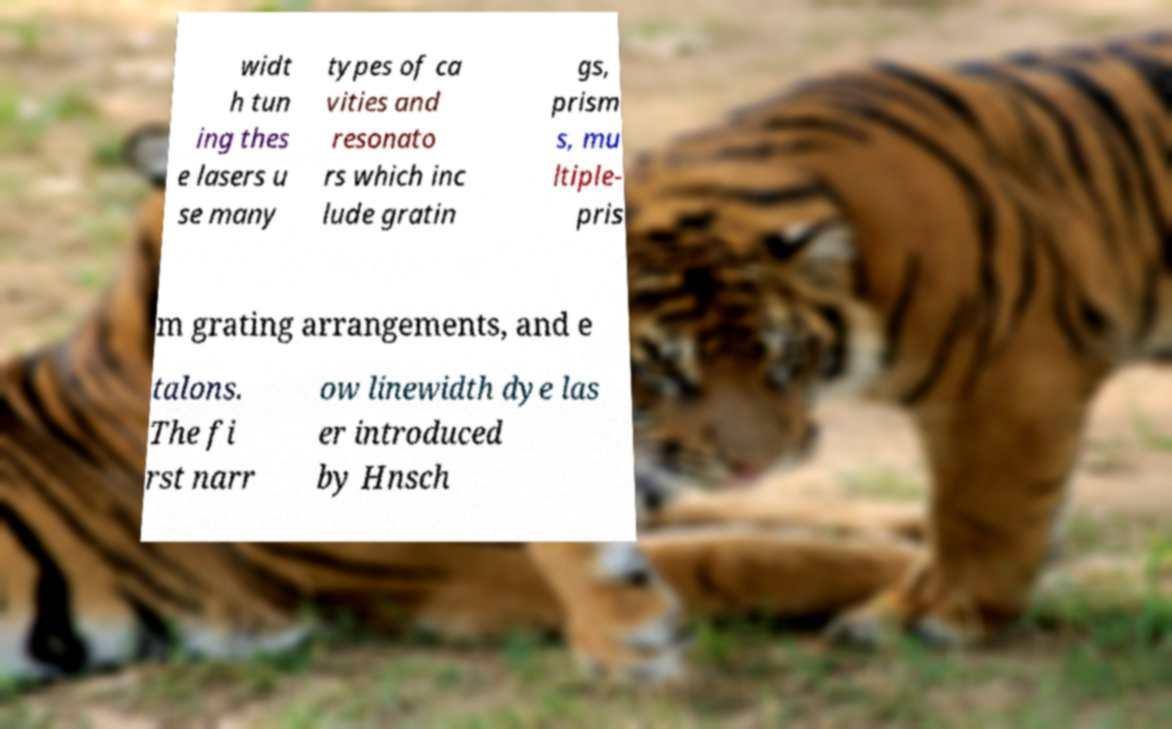Can you read and provide the text displayed in the image?This photo seems to have some interesting text. Can you extract and type it out for me? widt h tun ing thes e lasers u se many types of ca vities and resonato rs which inc lude gratin gs, prism s, mu ltiple- pris m grating arrangements, and e talons. The fi rst narr ow linewidth dye las er introduced by Hnsch 